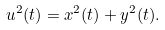Convert formula to latex. <formula><loc_0><loc_0><loc_500><loc_500>u ^ { 2 } ( t ) = x ^ { 2 } ( t ) + y ^ { 2 } ( t ) .</formula> 